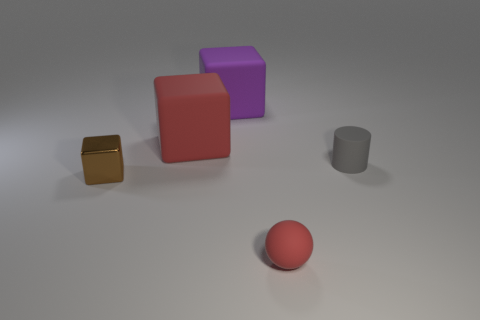Add 1 small purple matte spheres. How many objects exist? 6 Subtract all cylinders. How many objects are left? 4 Subtract all large green metallic things. Subtract all small shiny things. How many objects are left? 4 Add 2 gray matte things. How many gray matte things are left? 3 Add 4 small yellow matte cylinders. How many small yellow matte cylinders exist? 4 Subtract 1 brown blocks. How many objects are left? 4 